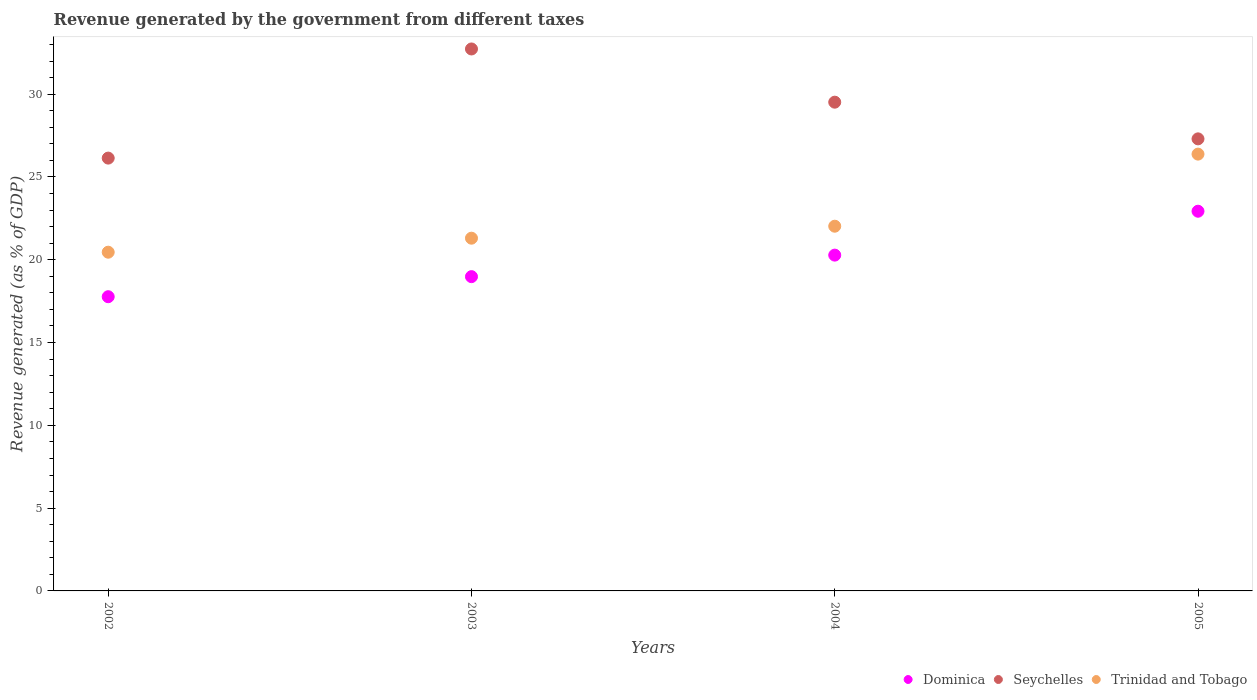How many different coloured dotlines are there?
Make the answer very short. 3. Is the number of dotlines equal to the number of legend labels?
Offer a terse response. Yes. What is the revenue generated by the government in Dominica in 2005?
Provide a succinct answer. 22.93. Across all years, what is the maximum revenue generated by the government in Seychelles?
Give a very brief answer. 32.73. Across all years, what is the minimum revenue generated by the government in Seychelles?
Your response must be concise. 26.14. In which year was the revenue generated by the government in Dominica maximum?
Ensure brevity in your answer.  2005. What is the total revenue generated by the government in Trinidad and Tobago in the graph?
Keep it short and to the point. 90.16. What is the difference between the revenue generated by the government in Dominica in 2002 and that in 2005?
Your answer should be compact. -5.16. What is the difference between the revenue generated by the government in Dominica in 2002 and the revenue generated by the government in Seychelles in 2003?
Your answer should be compact. -14.96. What is the average revenue generated by the government in Trinidad and Tobago per year?
Give a very brief answer. 22.54. In the year 2002, what is the difference between the revenue generated by the government in Seychelles and revenue generated by the government in Dominica?
Provide a succinct answer. 8.37. What is the ratio of the revenue generated by the government in Trinidad and Tobago in 2002 to that in 2005?
Offer a very short reply. 0.78. What is the difference between the highest and the second highest revenue generated by the government in Dominica?
Provide a short and direct response. 2.65. What is the difference between the highest and the lowest revenue generated by the government in Trinidad and Tobago?
Provide a succinct answer. 5.92. In how many years, is the revenue generated by the government in Seychelles greater than the average revenue generated by the government in Seychelles taken over all years?
Offer a terse response. 2. Is it the case that in every year, the sum of the revenue generated by the government in Trinidad and Tobago and revenue generated by the government in Dominica  is greater than the revenue generated by the government in Seychelles?
Make the answer very short. Yes. Does the revenue generated by the government in Seychelles monotonically increase over the years?
Your answer should be compact. No. Is the revenue generated by the government in Trinidad and Tobago strictly less than the revenue generated by the government in Dominica over the years?
Keep it short and to the point. No. How many dotlines are there?
Make the answer very short. 3. Are the values on the major ticks of Y-axis written in scientific E-notation?
Ensure brevity in your answer.  No. Does the graph contain any zero values?
Ensure brevity in your answer.  No. Where does the legend appear in the graph?
Provide a succinct answer. Bottom right. What is the title of the graph?
Keep it short and to the point. Revenue generated by the government from different taxes. What is the label or title of the Y-axis?
Your answer should be very brief. Revenue generated (as % of GDP). What is the Revenue generated (as % of GDP) of Dominica in 2002?
Offer a terse response. 17.77. What is the Revenue generated (as % of GDP) in Seychelles in 2002?
Give a very brief answer. 26.14. What is the Revenue generated (as % of GDP) in Trinidad and Tobago in 2002?
Provide a short and direct response. 20.46. What is the Revenue generated (as % of GDP) of Dominica in 2003?
Provide a short and direct response. 18.98. What is the Revenue generated (as % of GDP) in Seychelles in 2003?
Make the answer very short. 32.73. What is the Revenue generated (as % of GDP) in Trinidad and Tobago in 2003?
Your response must be concise. 21.3. What is the Revenue generated (as % of GDP) in Dominica in 2004?
Keep it short and to the point. 20.28. What is the Revenue generated (as % of GDP) of Seychelles in 2004?
Keep it short and to the point. 29.52. What is the Revenue generated (as % of GDP) of Trinidad and Tobago in 2004?
Give a very brief answer. 22.03. What is the Revenue generated (as % of GDP) of Dominica in 2005?
Provide a short and direct response. 22.93. What is the Revenue generated (as % of GDP) of Seychelles in 2005?
Ensure brevity in your answer.  27.3. What is the Revenue generated (as % of GDP) in Trinidad and Tobago in 2005?
Provide a succinct answer. 26.38. Across all years, what is the maximum Revenue generated (as % of GDP) of Dominica?
Give a very brief answer. 22.93. Across all years, what is the maximum Revenue generated (as % of GDP) in Seychelles?
Keep it short and to the point. 32.73. Across all years, what is the maximum Revenue generated (as % of GDP) in Trinidad and Tobago?
Provide a succinct answer. 26.38. Across all years, what is the minimum Revenue generated (as % of GDP) in Dominica?
Offer a terse response. 17.77. Across all years, what is the minimum Revenue generated (as % of GDP) in Seychelles?
Your response must be concise. 26.14. Across all years, what is the minimum Revenue generated (as % of GDP) of Trinidad and Tobago?
Keep it short and to the point. 20.46. What is the total Revenue generated (as % of GDP) in Dominica in the graph?
Make the answer very short. 79.96. What is the total Revenue generated (as % of GDP) in Seychelles in the graph?
Provide a succinct answer. 115.68. What is the total Revenue generated (as % of GDP) of Trinidad and Tobago in the graph?
Offer a very short reply. 90.16. What is the difference between the Revenue generated (as % of GDP) in Dominica in 2002 and that in 2003?
Your response must be concise. -1.21. What is the difference between the Revenue generated (as % of GDP) in Seychelles in 2002 and that in 2003?
Provide a succinct answer. -6.59. What is the difference between the Revenue generated (as % of GDP) in Trinidad and Tobago in 2002 and that in 2003?
Ensure brevity in your answer.  -0.85. What is the difference between the Revenue generated (as % of GDP) in Dominica in 2002 and that in 2004?
Offer a terse response. -2.51. What is the difference between the Revenue generated (as % of GDP) of Seychelles in 2002 and that in 2004?
Give a very brief answer. -3.38. What is the difference between the Revenue generated (as % of GDP) of Trinidad and Tobago in 2002 and that in 2004?
Make the answer very short. -1.57. What is the difference between the Revenue generated (as % of GDP) in Dominica in 2002 and that in 2005?
Your response must be concise. -5.16. What is the difference between the Revenue generated (as % of GDP) of Seychelles in 2002 and that in 2005?
Provide a succinct answer. -1.16. What is the difference between the Revenue generated (as % of GDP) of Trinidad and Tobago in 2002 and that in 2005?
Offer a very short reply. -5.92. What is the difference between the Revenue generated (as % of GDP) in Dominica in 2003 and that in 2004?
Provide a succinct answer. -1.3. What is the difference between the Revenue generated (as % of GDP) of Seychelles in 2003 and that in 2004?
Give a very brief answer. 3.21. What is the difference between the Revenue generated (as % of GDP) of Trinidad and Tobago in 2003 and that in 2004?
Offer a very short reply. -0.72. What is the difference between the Revenue generated (as % of GDP) in Dominica in 2003 and that in 2005?
Keep it short and to the point. -3.95. What is the difference between the Revenue generated (as % of GDP) of Seychelles in 2003 and that in 2005?
Ensure brevity in your answer.  5.43. What is the difference between the Revenue generated (as % of GDP) of Trinidad and Tobago in 2003 and that in 2005?
Offer a terse response. -5.08. What is the difference between the Revenue generated (as % of GDP) of Dominica in 2004 and that in 2005?
Provide a succinct answer. -2.65. What is the difference between the Revenue generated (as % of GDP) of Seychelles in 2004 and that in 2005?
Ensure brevity in your answer.  2.22. What is the difference between the Revenue generated (as % of GDP) in Trinidad and Tobago in 2004 and that in 2005?
Keep it short and to the point. -4.35. What is the difference between the Revenue generated (as % of GDP) in Dominica in 2002 and the Revenue generated (as % of GDP) in Seychelles in 2003?
Your answer should be very brief. -14.96. What is the difference between the Revenue generated (as % of GDP) of Dominica in 2002 and the Revenue generated (as % of GDP) of Trinidad and Tobago in 2003?
Give a very brief answer. -3.53. What is the difference between the Revenue generated (as % of GDP) in Seychelles in 2002 and the Revenue generated (as % of GDP) in Trinidad and Tobago in 2003?
Provide a short and direct response. 4.84. What is the difference between the Revenue generated (as % of GDP) of Dominica in 2002 and the Revenue generated (as % of GDP) of Seychelles in 2004?
Offer a very short reply. -11.75. What is the difference between the Revenue generated (as % of GDP) in Dominica in 2002 and the Revenue generated (as % of GDP) in Trinidad and Tobago in 2004?
Give a very brief answer. -4.26. What is the difference between the Revenue generated (as % of GDP) of Seychelles in 2002 and the Revenue generated (as % of GDP) of Trinidad and Tobago in 2004?
Keep it short and to the point. 4.11. What is the difference between the Revenue generated (as % of GDP) of Dominica in 2002 and the Revenue generated (as % of GDP) of Seychelles in 2005?
Offer a very short reply. -9.53. What is the difference between the Revenue generated (as % of GDP) of Dominica in 2002 and the Revenue generated (as % of GDP) of Trinidad and Tobago in 2005?
Your answer should be compact. -8.61. What is the difference between the Revenue generated (as % of GDP) in Seychelles in 2002 and the Revenue generated (as % of GDP) in Trinidad and Tobago in 2005?
Offer a very short reply. -0.24. What is the difference between the Revenue generated (as % of GDP) of Dominica in 2003 and the Revenue generated (as % of GDP) of Seychelles in 2004?
Give a very brief answer. -10.54. What is the difference between the Revenue generated (as % of GDP) in Dominica in 2003 and the Revenue generated (as % of GDP) in Trinidad and Tobago in 2004?
Give a very brief answer. -3.05. What is the difference between the Revenue generated (as % of GDP) of Seychelles in 2003 and the Revenue generated (as % of GDP) of Trinidad and Tobago in 2004?
Offer a terse response. 10.7. What is the difference between the Revenue generated (as % of GDP) in Dominica in 2003 and the Revenue generated (as % of GDP) in Seychelles in 2005?
Make the answer very short. -8.32. What is the difference between the Revenue generated (as % of GDP) of Dominica in 2003 and the Revenue generated (as % of GDP) of Trinidad and Tobago in 2005?
Your answer should be compact. -7.4. What is the difference between the Revenue generated (as % of GDP) in Seychelles in 2003 and the Revenue generated (as % of GDP) in Trinidad and Tobago in 2005?
Keep it short and to the point. 6.35. What is the difference between the Revenue generated (as % of GDP) of Dominica in 2004 and the Revenue generated (as % of GDP) of Seychelles in 2005?
Give a very brief answer. -7.02. What is the difference between the Revenue generated (as % of GDP) of Dominica in 2004 and the Revenue generated (as % of GDP) of Trinidad and Tobago in 2005?
Your answer should be very brief. -6.1. What is the difference between the Revenue generated (as % of GDP) in Seychelles in 2004 and the Revenue generated (as % of GDP) in Trinidad and Tobago in 2005?
Your response must be concise. 3.14. What is the average Revenue generated (as % of GDP) of Dominica per year?
Keep it short and to the point. 19.99. What is the average Revenue generated (as % of GDP) in Seychelles per year?
Offer a very short reply. 28.92. What is the average Revenue generated (as % of GDP) in Trinidad and Tobago per year?
Make the answer very short. 22.54. In the year 2002, what is the difference between the Revenue generated (as % of GDP) in Dominica and Revenue generated (as % of GDP) in Seychelles?
Keep it short and to the point. -8.37. In the year 2002, what is the difference between the Revenue generated (as % of GDP) in Dominica and Revenue generated (as % of GDP) in Trinidad and Tobago?
Your answer should be compact. -2.69. In the year 2002, what is the difference between the Revenue generated (as % of GDP) of Seychelles and Revenue generated (as % of GDP) of Trinidad and Tobago?
Provide a succinct answer. 5.68. In the year 2003, what is the difference between the Revenue generated (as % of GDP) in Dominica and Revenue generated (as % of GDP) in Seychelles?
Offer a terse response. -13.75. In the year 2003, what is the difference between the Revenue generated (as % of GDP) of Dominica and Revenue generated (as % of GDP) of Trinidad and Tobago?
Your answer should be very brief. -2.32. In the year 2003, what is the difference between the Revenue generated (as % of GDP) of Seychelles and Revenue generated (as % of GDP) of Trinidad and Tobago?
Ensure brevity in your answer.  11.43. In the year 2004, what is the difference between the Revenue generated (as % of GDP) of Dominica and Revenue generated (as % of GDP) of Seychelles?
Ensure brevity in your answer.  -9.24. In the year 2004, what is the difference between the Revenue generated (as % of GDP) in Dominica and Revenue generated (as % of GDP) in Trinidad and Tobago?
Give a very brief answer. -1.75. In the year 2004, what is the difference between the Revenue generated (as % of GDP) in Seychelles and Revenue generated (as % of GDP) in Trinidad and Tobago?
Keep it short and to the point. 7.49. In the year 2005, what is the difference between the Revenue generated (as % of GDP) in Dominica and Revenue generated (as % of GDP) in Seychelles?
Your response must be concise. -4.37. In the year 2005, what is the difference between the Revenue generated (as % of GDP) in Dominica and Revenue generated (as % of GDP) in Trinidad and Tobago?
Offer a very short reply. -3.45. In the year 2005, what is the difference between the Revenue generated (as % of GDP) in Seychelles and Revenue generated (as % of GDP) in Trinidad and Tobago?
Provide a succinct answer. 0.92. What is the ratio of the Revenue generated (as % of GDP) in Dominica in 2002 to that in 2003?
Offer a terse response. 0.94. What is the ratio of the Revenue generated (as % of GDP) of Seychelles in 2002 to that in 2003?
Offer a terse response. 0.8. What is the ratio of the Revenue generated (as % of GDP) of Trinidad and Tobago in 2002 to that in 2003?
Make the answer very short. 0.96. What is the ratio of the Revenue generated (as % of GDP) in Dominica in 2002 to that in 2004?
Make the answer very short. 0.88. What is the ratio of the Revenue generated (as % of GDP) in Seychelles in 2002 to that in 2004?
Offer a very short reply. 0.89. What is the ratio of the Revenue generated (as % of GDP) of Trinidad and Tobago in 2002 to that in 2004?
Provide a succinct answer. 0.93. What is the ratio of the Revenue generated (as % of GDP) of Dominica in 2002 to that in 2005?
Offer a terse response. 0.77. What is the ratio of the Revenue generated (as % of GDP) of Seychelles in 2002 to that in 2005?
Offer a very short reply. 0.96. What is the ratio of the Revenue generated (as % of GDP) of Trinidad and Tobago in 2002 to that in 2005?
Your response must be concise. 0.78. What is the ratio of the Revenue generated (as % of GDP) of Dominica in 2003 to that in 2004?
Your answer should be very brief. 0.94. What is the ratio of the Revenue generated (as % of GDP) of Seychelles in 2003 to that in 2004?
Your response must be concise. 1.11. What is the ratio of the Revenue generated (as % of GDP) of Trinidad and Tobago in 2003 to that in 2004?
Keep it short and to the point. 0.97. What is the ratio of the Revenue generated (as % of GDP) of Dominica in 2003 to that in 2005?
Give a very brief answer. 0.83. What is the ratio of the Revenue generated (as % of GDP) in Seychelles in 2003 to that in 2005?
Keep it short and to the point. 1.2. What is the ratio of the Revenue generated (as % of GDP) in Trinidad and Tobago in 2003 to that in 2005?
Provide a short and direct response. 0.81. What is the ratio of the Revenue generated (as % of GDP) in Dominica in 2004 to that in 2005?
Keep it short and to the point. 0.88. What is the ratio of the Revenue generated (as % of GDP) of Seychelles in 2004 to that in 2005?
Make the answer very short. 1.08. What is the ratio of the Revenue generated (as % of GDP) of Trinidad and Tobago in 2004 to that in 2005?
Your answer should be compact. 0.83. What is the difference between the highest and the second highest Revenue generated (as % of GDP) in Dominica?
Give a very brief answer. 2.65. What is the difference between the highest and the second highest Revenue generated (as % of GDP) in Seychelles?
Keep it short and to the point. 3.21. What is the difference between the highest and the second highest Revenue generated (as % of GDP) of Trinidad and Tobago?
Offer a very short reply. 4.35. What is the difference between the highest and the lowest Revenue generated (as % of GDP) in Dominica?
Offer a very short reply. 5.16. What is the difference between the highest and the lowest Revenue generated (as % of GDP) of Seychelles?
Make the answer very short. 6.59. What is the difference between the highest and the lowest Revenue generated (as % of GDP) of Trinidad and Tobago?
Your answer should be very brief. 5.92. 